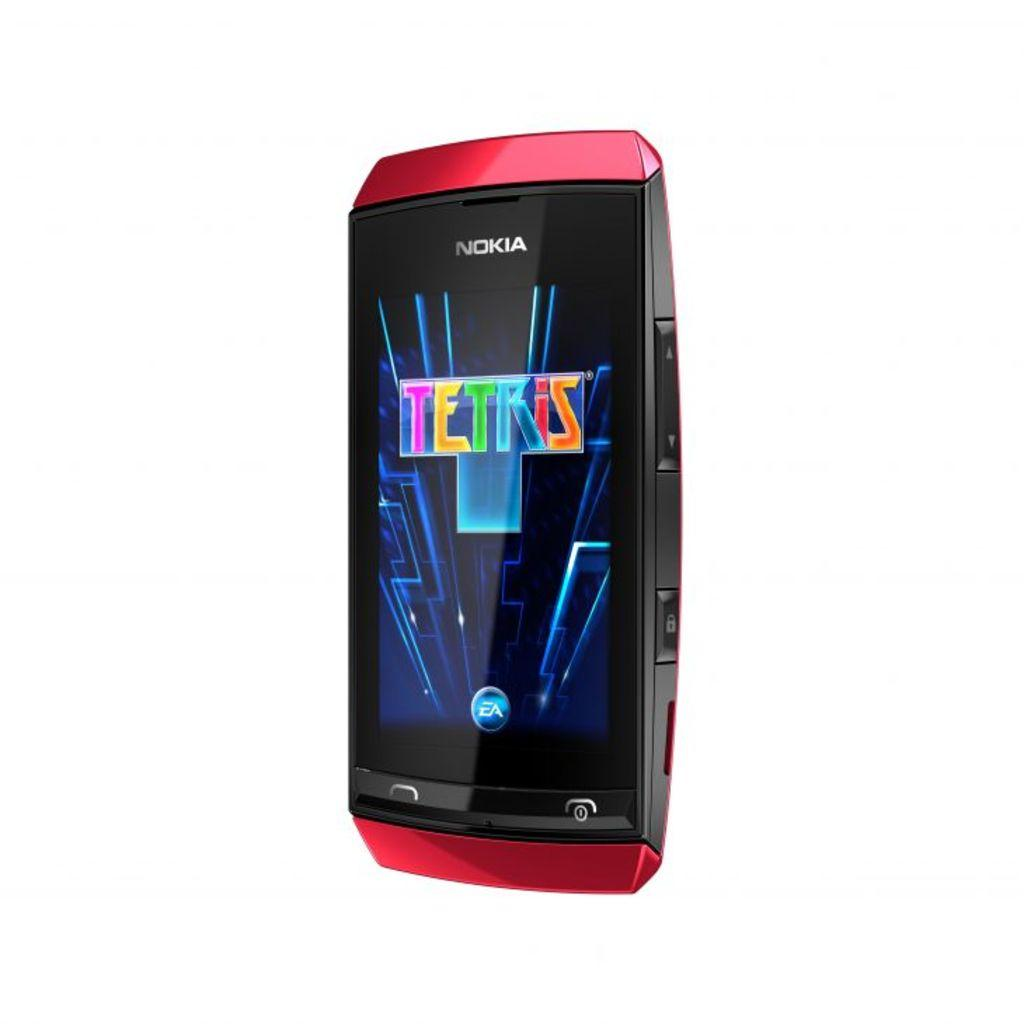<image>
Offer a succinct explanation of the picture presented. The red and black mobile phone is made by Nokia. 